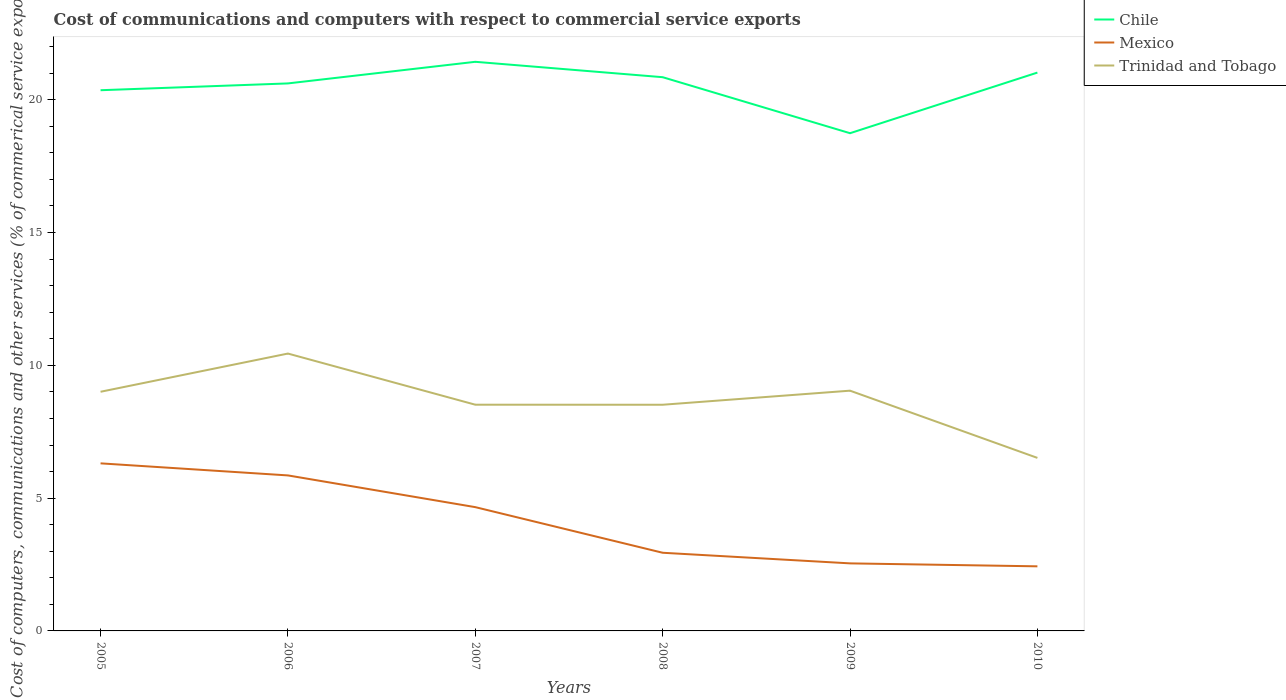Does the line corresponding to Trinidad and Tobago intersect with the line corresponding to Chile?
Provide a succinct answer. No. Across all years, what is the maximum cost of communications and computers in Trinidad and Tobago?
Make the answer very short. 6.51. What is the total cost of communications and computers in Trinidad and Tobago in the graph?
Provide a short and direct response. 2. What is the difference between the highest and the second highest cost of communications and computers in Trinidad and Tobago?
Your answer should be very brief. 3.93. Is the cost of communications and computers in Chile strictly greater than the cost of communications and computers in Mexico over the years?
Your answer should be very brief. No. Does the graph contain grids?
Provide a succinct answer. No. Where does the legend appear in the graph?
Your response must be concise. Top right. How many legend labels are there?
Keep it short and to the point. 3. How are the legend labels stacked?
Keep it short and to the point. Vertical. What is the title of the graph?
Your response must be concise. Cost of communications and computers with respect to commercial service exports. Does "France" appear as one of the legend labels in the graph?
Your answer should be compact. No. What is the label or title of the X-axis?
Keep it short and to the point. Years. What is the label or title of the Y-axis?
Your answer should be very brief. Cost of computers, communications and other services (% of commerical service exports). What is the Cost of computers, communications and other services (% of commerical service exports) of Chile in 2005?
Make the answer very short. 20.36. What is the Cost of computers, communications and other services (% of commerical service exports) of Mexico in 2005?
Make the answer very short. 6.31. What is the Cost of computers, communications and other services (% of commerical service exports) of Trinidad and Tobago in 2005?
Provide a short and direct response. 9. What is the Cost of computers, communications and other services (% of commerical service exports) in Chile in 2006?
Keep it short and to the point. 20.61. What is the Cost of computers, communications and other services (% of commerical service exports) in Mexico in 2006?
Offer a terse response. 5.85. What is the Cost of computers, communications and other services (% of commerical service exports) in Trinidad and Tobago in 2006?
Offer a terse response. 10.44. What is the Cost of computers, communications and other services (% of commerical service exports) of Chile in 2007?
Provide a short and direct response. 21.43. What is the Cost of computers, communications and other services (% of commerical service exports) of Mexico in 2007?
Your answer should be very brief. 4.66. What is the Cost of computers, communications and other services (% of commerical service exports) in Trinidad and Tobago in 2007?
Your answer should be compact. 8.52. What is the Cost of computers, communications and other services (% of commerical service exports) in Chile in 2008?
Keep it short and to the point. 20.85. What is the Cost of computers, communications and other services (% of commerical service exports) of Mexico in 2008?
Offer a very short reply. 2.94. What is the Cost of computers, communications and other services (% of commerical service exports) in Trinidad and Tobago in 2008?
Provide a short and direct response. 8.52. What is the Cost of computers, communications and other services (% of commerical service exports) in Chile in 2009?
Provide a short and direct response. 18.74. What is the Cost of computers, communications and other services (% of commerical service exports) in Mexico in 2009?
Keep it short and to the point. 2.54. What is the Cost of computers, communications and other services (% of commerical service exports) of Trinidad and Tobago in 2009?
Your answer should be compact. 9.05. What is the Cost of computers, communications and other services (% of commerical service exports) in Chile in 2010?
Give a very brief answer. 21.02. What is the Cost of computers, communications and other services (% of commerical service exports) in Mexico in 2010?
Offer a very short reply. 2.43. What is the Cost of computers, communications and other services (% of commerical service exports) in Trinidad and Tobago in 2010?
Give a very brief answer. 6.51. Across all years, what is the maximum Cost of computers, communications and other services (% of commerical service exports) in Chile?
Provide a succinct answer. 21.43. Across all years, what is the maximum Cost of computers, communications and other services (% of commerical service exports) of Mexico?
Your response must be concise. 6.31. Across all years, what is the maximum Cost of computers, communications and other services (% of commerical service exports) in Trinidad and Tobago?
Your answer should be very brief. 10.44. Across all years, what is the minimum Cost of computers, communications and other services (% of commerical service exports) of Chile?
Provide a succinct answer. 18.74. Across all years, what is the minimum Cost of computers, communications and other services (% of commerical service exports) in Mexico?
Provide a short and direct response. 2.43. Across all years, what is the minimum Cost of computers, communications and other services (% of commerical service exports) in Trinidad and Tobago?
Ensure brevity in your answer.  6.51. What is the total Cost of computers, communications and other services (% of commerical service exports) of Chile in the graph?
Give a very brief answer. 123.01. What is the total Cost of computers, communications and other services (% of commerical service exports) of Mexico in the graph?
Keep it short and to the point. 24.74. What is the total Cost of computers, communications and other services (% of commerical service exports) of Trinidad and Tobago in the graph?
Your answer should be very brief. 52.04. What is the difference between the Cost of computers, communications and other services (% of commerical service exports) of Chile in 2005 and that in 2006?
Your answer should be very brief. -0.26. What is the difference between the Cost of computers, communications and other services (% of commerical service exports) in Mexico in 2005 and that in 2006?
Give a very brief answer. 0.45. What is the difference between the Cost of computers, communications and other services (% of commerical service exports) in Trinidad and Tobago in 2005 and that in 2006?
Ensure brevity in your answer.  -1.44. What is the difference between the Cost of computers, communications and other services (% of commerical service exports) of Chile in 2005 and that in 2007?
Provide a short and direct response. -1.07. What is the difference between the Cost of computers, communications and other services (% of commerical service exports) of Mexico in 2005 and that in 2007?
Make the answer very short. 1.65. What is the difference between the Cost of computers, communications and other services (% of commerical service exports) of Trinidad and Tobago in 2005 and that in 2007?
Offer a very short reply. 0.49. What is the difference between the Cost of computers, communications and other services (% of commerical service exports) in Chile in 2005 and that in 2008?
Offer a terse response. -0.49. What is the difference between the Cost of computers, communications and other services (% of commerical service exports) of Mexico in 2005 and that in 2008?
Provide a succinct answer. 3.37. What is the difference between the Cost of computers, communications and other services (% of commerical service exports) of Trinidad and Tobago in 2005 and that in 2008?
Keep it short and to the point. 0.49. What is the difference between the Cost of computers, communications and other services (% of commerical service exports) in Chile in 2005 and that in 2009?
Keep it short and to the point. 1.62. What is the difference between the Cost of computers, communications and other services (% of commerical service exports) of Mexico in 2005 and that in 2009?
Offer a very short reply. 3.77. What is the difference between the Cost of computers, communications and other services (% of commerical service exports) in Trinidad and Tobago in 2005 and that in 2009?
Your answer should be compact. -0.04. What is the difference between the Cost of computers, communications and other services (% of commerical service exports) in Chile in 2005 and that in 2010?
Offer a terse response. -0.66. What is the difference between the Cost of computers, communications and other services (% of commerical service exports) of Mexico in 2005 and that in 2010?
Your answer should be compact. 3.88. What is the difference between the Cost of computers, communications and other services (% of commerical service exports) in Trinidad and Tobago in 2005 and that in 2010?
Provide a short and direct response. 2.49. What is the difference between the Cost of computers, communications and other services (% of commerical service exports) in Chile in 2006 and that in 2007?
Your answer should be very brief. -0.81. What is the difference between the Cost of computers, communications and other services (% of commerical service exports) in Mexico in 2006 and that in 2007?
Keep it short and to the point. 1.19. What is the difference between the Cost of computers, communications and other services (% of commerical service exports) in Trinidad and Tobago in 2006 and that in 2007?
Provide a short and direct response. 1.93. What is the difference between the Cost of computers, communications and other services (% of commerical service exports) of Chile in 2006 and that in 2008?
Keep it short and to the point. -0.23. What is the difference between the Cost of computers, communications and other services (% of commerical service exports) in Mexico in 2006 and that in 2008?
Keep it short and to the point. 2.91. What is the difference between the Cost of computers, communications and other services (% of commerical service exports) of Trinidad and Tobago in 2006 and that in 2008?
Give a very brief answer. 1.93. What is the difference between the Cost of computers, communications and other services (% of commerical service exports) of Chile in 2006 and that in 2009?
Provide a succinct answer. 1.87. What is the difference between the Cost of computers, communications and other services (% of commerical service exports) of Mexico in 2006 and that in 2009?
Make the answer very short. 3.31. What is the difference between the Cost of computers, communications and other services (% of commerical service exports) in Trinidad and Tobago in 2006 and that in 2009?
Provide a succinct answer. 1.4. What is the difference between the Cost of computers, communications and other services (% of commerical service exports) of Chile in 2006 and that in 2010?
Provide a short and direct response. -0.41. What is the difference between the Cost of computers, communications and other services (% of commerical service exports) in Mexico in 2006 and that in 2010?
Your response must be concise. 3.42. What is the difference between the Cost of computers, communications and other services (% of commerical service exports) in Trinidad and Tobago in 2006 and that in 2010?
Offer a very short reply. 3.93. What is the difference between the Cost of computers, communications and other services (% of commerical service exports) in Chile in 2007 and that in 2008?
Give a very brief answer. 0.58. What is the difference between the Cost of computers, communications and other services (% of commerical service exports) of Mexico in 2007 and that in 2008?
Provide a short and direct response. 1.72. What is the difference between the Cost of computers, communications and other services (% of commerical service exports) of Trinidad and Tobago in 2007 and that in 2008?
Make the answer very short. 0. What is the difference between the Cost of computers, communications and other services (% of commerical service exports) of Chile in 2007 and that in 2009?
Make the answer very short. 2.69. What is the difference between the Cost of computers, communications and other services (% of commerical service exports) of Mexico in 2007 and that in 2009?
Provide a short and direct response. 2.12. What is the difference between the Cost of computers, communications and other services (% of commerical service exports) of Trinidad and Tobago in 2007 and that in 2009?
Provide a short and direct response. -0.53. What is the difference between the Cost of computers, communications and other services (% of commerical service exports) in Chile in 2007 and that in 2010?
Provide a short and direct response. 0.41. What is the difference between the Cost of computers, communications and other services (% of commerical service exports) of Mexico in 2007 and that in 2010?
Provide a succinct answer. 2.23. What is the difference between the Cost of computers, communications and other services (% of commerical service exports) of Trinidad and Tobago in 2007 and that in 2010?
Give a very brief answer. 2. What is the difference between the Cost of computers, communications and other services (% of commerical service exports) of Chile in 2008 and that in 2009?
Provide a short and direct response. 2.11. What is the difference between the Cost of computers, communications and other services (% of commerical service exports) of Mexico in 2008 and that in 2009?
Offer a terse response. 0.4. What is the difference between the Cost of computers, communications and other services (% of commerical service exports) in Trinidad and Tobago in 2008 and that in 2009?
Give a very brief answer. -0.53. What is the difference between the Cost of computers, communications and other services (% of commerical service exports) in Chile in 2008 and that in 2010?
Offer a terse response. -0.17. What is the difference between the Cost of computers, communications and other services (% of commerical service exports) of Mexico in 2008 and that in 2010?
Keep it short and to the point. 0.51. What is the difference between the Cost of computers, communications and other services (% of commerical service exports) in Trinidad and Tobago in 2008 and that in 2010?
Offer a terse response. 2. What is the difference between the Cost of computers, communications and other services (% of commerical service exports) in Chile in 2009 and that in 2010?
Your answer should be compact. -2.28. What is the difference between the Cost of computers, communications and other services (% of commerical service exports) of Mexico in 2009 and that in 2010?
Ensure brevity in your answer.  0.11. What is the difference between the Cost of computers, communications and other services (% of commerical service exports) of Trinidad and Tobago in 2009 and that in 2010?
Your answer should be compact. 2.53. What is the difference between the Cost of computers, communications and other services (% of commerical service exports) in Chile in 2005 and the Cost of computers, communications and other services (% of commerical service exports) in Mexico in 2006?
Your answer should be very brief. 14.5. What is the difference between the Cost of computers, communications and other services (% of commerical service exports) of Chile in 2005 and the Cost of computers, communications and other services (% of commerical service exports) of Trinidad and Tobago in 2006?
Provide a succinct answer. 9.91. What is the difference between the Cost of computers, communications and other services (% of commerical service exports) of Mexico in 2005 and the Cost of computers, communications and other services (% of commerical service exports) of Trinidad and Tobago in 2006?
Your answer should be very brief. -4.13. What is the difference between the Cost of computers, communications and other services (% of commerical service exports) in Chile in 2005 and the Cost of computers, communications and other services (% of commerical service exports) in Mexico in 2007?
Make the answer very short. 15.7. What is the difference between the Cost of computers, communications and other services (% of commerical service exports) of Chile in 2005 and the Cost of computers, communications and other services (% of commerical service exports) of Trinidad and Tobago in 2007?
Offer a terse response. 11.84. What is the difference between the Cost of computers, communications and other services (% of commerical service exports) of Mexico in 2005 and the Cost of computers, communications and other services (% of commerical service exports) of Trinidad and Tobago in 2007?
Give a very brief answer. -2.21. What is the difference between the Cost of computers, communications and other services (% of commerical service exports) of Chile in 2005 and the Cost of computers, communications and other services (% of commerical service exports) of Mexico in 2008?
Ensure brevity in your answer.  17.41. What is the difference between the Cost of computers, communications and other services (% of commerical service exports) of Chile in 2005 and the Cost of computers, communications and other services (% of commerical service exports) of Trinidad and Tobago in 2008?
Give a very brief answer. 11.84. What is the difference between the Cost of computers, communications and other services (% of commerical service exports) of Mexico in 2005 and the Cost of computers, communications and other services (% of commerical service exports) of Trinidad and Tobago in 2008?
Your answer should be compact. -2.21. What is the difference between the Cost of computers, communications and other services (% of commerical service exports) in Chile in 2005 and the Cost of computers, communications and other services (% of commerical service exports) in Mexico in 2009?
Your response must be concise. 17.81. What is the difference between the Cost of computers, communications and other services (% of commerical service exports) in Chile in 2005 and the Cost of computers, communications and other services (% of commerical service exports) in Trinidad and Tobago in 2009?
Your answer should be very brief. 11.31. What is the difference between the Cost of computers, communications and other services (% of commerical service exports) of Mexico in 2005 and the Cost of computers, communications and other services (% of commerical service exports) of Trinidad and Tobago in 2009?
Provide a short and direct response. -2.74. What is the difference between the Cost of computers, communications and other services (% of commerical service exports) in Chile in 2005 and the Cost of computers, communications and other services (% of commerical service exports) in Mexico in 2010?
Keep it short and to the point. 17.93. What is the difference between the Cost of computers, communications and other services (% of commerical service exports) in Chile in 2005 and the Cost of computers, communications and other services (% of commerical service exports) in Trinidad and Tobago in 2010?
Offer a terse response. 13.84. What is the difference between the Cost of computers, communications and other services (% of commerical service exports) of Mexico in 2005 and the Cost of computers, communications and other services (% of commerical service exports) of Trinidad and Tobago in 2010?
Offer a very short reply. -0.21. What is the difference between the Cost of computers, communications and other services (% of commerical service exports) in Chile in 2006 and the Cost of computers, communications and other services (% of commerical service exports) in Mexico in 2007?
Provide a short and direct response. 15.95. What is the difference between the Cost of computers, communications and other services (% of commerical service exports) of Chile in 2006 and the Cost of computers, communications and other services (% of commerical service exports) of Trinidad and Tobago in 2007?
Your response must be concise. 12.1. What is the difference between the Cost of computers, communications and other services (% of commerical service exports) in Mexico in 2006 and the Cost of computers, communications and other services (% of commerical service exports) in Trinidad and Tobago in 2007?
Your answer should be compact. -2.66. What is the difference between the Cost of computers, communications and other services (% of commerical service exports) of Chile in 2006 and the Cost of computers, communications and other services (% of commerical service exports) of Mexico in 2008?
Keep it short and to the point. 17.67. What is the difference between the Cost of computers, communications and other services (% of commerical service exports) in Chile in 2006 and the Cost of computers, communications and other services (% of commerical service exports) in Trinidad and Tobago in 2008?
Your answer should be very brief. 12.1. What is the difference between the Cost of computers, communications and other services (% of commerical service exports) in Mexico in 2006 and the Cost of computers, communications and other services (% of commerical service exports) in Trinidad and Tobago in 2008?
Keep it short and to the point. -2.66. What is the difference between the Cost of computers, communications and other services (% of commerical service exports) of Chile in 2006 and the Cost of computers, communications and other services (% of commerical service exports) of Mexico in 2009?
Provide a short and direct response. 18.07. What is the difference between the Cost of computers, communications and other services (% of commerical service exports) in Chile in 2006 and the Cost of computers, communications and other services (% of commerical service exports) in Trinidad and Tobago in 2009?
Provide a succinct answer. 11.57. What is the difference between the Cost of computers, communications and other services (% of commerical service exports) of Mexico in 2006 and the Cost of computers, communications and other services (% of commerical service exports) of Trinidad and Tobago in 2009?
Your answer should be compact. -3.19. What is the difference between the Cost of computers, communications and other services (% of commerical service exports) of Chile in 2006 and the Cost of computers, communications and other services (% of commerical service exports) of Mexico in 2010?
Keep it short and to the point. 18.18. What is the difference between the Cost of computers, communications and other services (% of commerical service exports) in Chile in 2006 and the Cost of computers, communications and other services (% of commerical service exports) in Trinidad and Tobago in 2010?
Keep it short and to the point. 14.1. What is the difference between the Cost of computers, communications and other services (% of commerical service exports) of Mexico in 2006 and the Cost of computers, communications and other services (% of commerical service exports) of Trinidad and Tobago in 2010?
Your response must be concise. -0.66. What is the difference between the Cost of computers, communications and other services (% of commerical service exports) in Chile in 2007 and the Cost of computers, communications and other services (% of commerical service exports) in Mexico in 2008?
Keep it short and to the point. 18.48. What is the difference between the Cost of computers, communications and other services (% of commerical service exports) in Chile in 2007 and the Cost of computers, communications and other services (% of commerical service exports) in Trinidad and Tobago in 2008?
Your answer should be very brief. 12.91. What is the difference between the Cost of computers, communications and other services (% of commerical service exports) of Mexico in 2007 and the Cost of computers, communications and other services (% of commerical service exports) of Trinidad and Tobago in 2008?
Give a very brief answer. -3.86. What is the difference between the Cost of computers, communications and other services (% of commerical service exports) in Chile in 2007 and the Cost of computers, communications and other services (% of commerical service exports) in Mexico in 2009?
Make the answer very short. 18.88. What is the difference between the Cost of computers, communications and other services (% of commerical service exports) in Chile in 2007 and the Cost of computers, communications and other services (% of commerical service exports) in Trinidad and Tobago in 2009?
Your answer should be compact. 12.38. What is the difference between the Cost of computers, communications and other services (% of commerical service exports) of Mexico in 2007 and the Cost of computers, communications and other services (% of commerical service exports) of Trinidad and Tobago in 2009?
Provide a succinct answer. -4.38. What is the difference between the Cost of computers, communications and other services (% of commerical service exports) of Chile in 2007 and the Cost of computers, communications and other services (% of commerical service exports) of Mexico in 2010?
Offer a very short reply. 19. What is the difference between the Cost of computers, communications and other services (% of commerical service exports) of Chile in 2007 and the Cost of computers, communications and other services (% of commerical service exports) of Trinidad and Tobago in 2010?
Offer a terse response. 14.91. What is the difference between the Cost of computers, communications and other services (% of commerical service exports) of Mexico in 2007 and the Cost of computers, communications and other services (% of commerical service exports) of Trinidad and Tobago in 2010?
Give a very brief answer. -1.85. What is the difference between the Cost of computers, communications and other services (% of commerical service exports) in Chile in 2008 and the Cost of computers, communications and other services (% of commerical service exports) in Mexico in 2009?
Provide a succinct answer. 18.3. What is the difference between the Cost of computers, communications and other services (% of commerical service exports) of Chile in 2008 and the Cost of computers, communications and other services (% of commerical service exports) of Trinidad and Tobago in 2009?
Your answer should be compact. 11.8. What is the difference between the Cost of computers, communications and other services (% of commerical service exports) in Mexico in 2008 and the Cost of computers, communications and other services (% of commerical service exports) in Trinidad and Tobago in 2009?
Provide a succinct answer. -6.1. What is the difference between the Cost of computers, communications and other services (% of commerical service exports) in Chile in 2008 and the Cost of computers, communications and other services (% of commerical service exports) in Mexico in 2010?
Provide a short and direct response. 18.42. What is the difference between the Cost of computers, communications and other services (% of commerical service exports) of Chile in 2008 and the Cost of computers, communications and other services (% of commerical service exports) of Trinidad and Tobago in 2010?
Your answer should be compact. 14.33. What is the difference between the Cost of computers, communications and other services (% of commerical service exports) of Mexico in 2008 and the Cost of computers, communications and other services (% of commerical service exports) of Trinidad and Tobago in 2010?
Keep it short and to the point. -3.57. What is the difference between the Cost of computers, communications and other services (% of commerical service exports) in Chile in 2009 and the Cost of computers, communications and other services (% of commerical service exports) in Mexico in 2010?
Your response must be concise. 16.31. What is the difference between the Cost of computers, communications and other services (% of commerical service exports) of Chile in 2009 and the Cost of computers, communications and other services (% of commerical service exports) of Trinidad and Tobago in 2010?
Ensure brevity in your answer.  12.22. What is the difference between the Cost of computers, communications and other services (% of commerical service exports) in Mexico in 2009 and the Cost of computers, communications and other services (% of commerical service exports) in Trinidad and Tobago in 2010?
Give a very brief answer. -3.97. What is the average Cost of computers, communications and other services (% of commerical service exports) in Chile per year?
Your answer should be very brief. 20.5. What is the average Cost of computers, communications and other services (% of commerical service exports) in Mexico per year?
Make the answer very short. 4.12. What is the average Cost of computers, communications and other services (% of commerical service exports) of Trinidad and Tobago per year?
Ensure brevity in your answer.  8.67. In the year 2005, what is the difference between the Cost of computers, communications and other services (% of commerical service exports) of Chile and Cost of computers, communications and other services (% of commerical service exports) of Mexico?
Offer a very short reply. 14.05. In the year 2005, what is the difference between the Cost of computers, communications and other services (% of commerical service exports) in Chile and Cost of computers, communications and other services (% of commerical service exports) in Trinidad and Tobago?
Offer a terse response. 11.35. In the year 2005, what is the difference between the Cost of computers, communications and other services (% of commerical service exports) of Mexico and Cost of computers, communications and other services (% of commerical service exports) of Trinidad and Tobago?
Your answer should be compact. -2.7. In the year 2006, what is the difference between the Cost of computers, communications and other services (% of commerical service exports) of Chile and Cost of computers, communications and other services (% of commerical service exports) of Mexico?
Make the answer very short. 14.76. In the year 2006, what is the difference between the Cost of computers, communications and other services (% of commerical service exports) of Chile and Cost of computers, communications and other services (% of commerical service exports) of Trinidad and Tobago?
Make the answer very short. 10.17. In the year 2006, what is the difference between the Cost of computers, communications and other services (% of commerical service exports) of Mexico and Cost of computers, communications and other services (% of commerical service exports) of Trinidad and Tobago?
Give a very brief answer. -4.59. In the year 2007, what is the difference between the Cost of computers, communications and other services (% of commerical service exports) of Chile and Cost of computers, communications and other services (% of commerical service exports) of Mexico?
Offer a terse response. 16.77. In the year 2007, what is the difference between the Cost of computers, communications and other services (% of commerical service exports) in Chile and Cost of computers, communications and other services (% of commerical service exports) in Trinidad and Tobago?
Offer a very short reply. 12.91. In the year 2007, what is the difference between the Cost of computers, communications and other services (% of commerical service exports) in Mexico and Cost of computers, communications and other services (% of commerical service exports) in Trinidad and Tobago?
Keep it short and to the point. -3.86. In the year 2008, what is the difference between the Cost of computers, communications and other services (% of commerical service exports) in Chile and Cost of computers, communications and other services (% of commerical service exports) in Mexico?
Make the answer very short. 17.91. In the year 2008, what is the difference between the Cost of computers, communications and other services (% of commerical service exports) in Chile and Cost of computers, communications and other services (% of commerical service exports) in Trinidad and Tobago?
Make the answer very short. 12.33. In the year 2008, what is the difference between the Cost of computers, communications and other services (% of commerical service exports) of Mexico and Cost of computers, communications and other services (% of commerical service exports) of Trinidad and Tobago?
Your answer should be very brief. -5.57. In the year 2009, what is the difference between the Cost of computers, communications and other services (% of commerical service exports) in Chile and Cost of computers, communications and other services (% of commerical service exports) in Mexico?
Keep it short and to the point. 16.2. In the year 2009, what is the difference between the Cost of computers, communications and other services (% of commerical service exports) in Chile and Cost of computers, communications and other services (% of commerical service exports) in Trinidad and Tobago?
Keep it short and to the point. 9.69. In the year 2009, what is the difference between the Cost of computers, communications and other services (% of commerical service exports) of Mexico and Cost of computers, communications and other services (% of commerical service exports) of Trinidad and Tobago?
Make the answer very short. -6.5. In the year 2010, what is the difference between the Cost of computers, communications and other services (% of commerical service exports) in Chile and Cost of computers, communications and other services (% of commerical service exports) in Mexico?
Your answer should be compact. 18.59. In the year 2010, what is the difference between the Cost of computers, communications and other services (% of commerical service exports) in Chile and Cost of computers, communications and other services (% of commerical service exports) in Trinidad and Tobago?
Your answer should be very brief. 14.51. In the year 2010, what is the difference between the Cost of computers, communications and other services (% of commerical service exports) in Mexico and Cost of computers, communications and other services (% of commerical service exports) in Trinidad and Tobago?
Your answer should be compact. -4.08. What is the ratio of the Cost of computers, communications and other services (% of commerical service exports) of Chile in 2005 to that in 2006?
Provide a succinct answer. 0.99. What is the ratio of the Cost of computers, communications and other services (% of commerical service exports) in Mexico in 2005 to that in 2006?
Your response must be concise. 1.08. What is the ratio of the Cost of computers, communications and other services (% of commerical service exports) of Trinidad and Tobago in 2005 to that in 2006?
Provide a short and direct response. 0.86. What is the ratio of the Cost of computers, communications and other services (% of commerical service exports) of Chile in 2005 to that in 2007?
Make the answer very short. 0.95. What is the ratio of the Cost of computers, communications and other services (% of commerical service exports) in Mexico in 2005 to that in 2007?
Ensure brevity in your answer.  1.35. What is the ratio of the Cost of computers, communications and other services (% of commerical service exports) in Trinidad and Tobago in 2005 to that in 2007?
Ensure brevity in your answer.  1.06. What is the ratio of the Cost of computers, communications and other services (% of commerical service exports) in Chile in 2005 to that in 2008?
Provide a succinct answer. 0.98. What is the ratio of the Cost of computers, communications and other services (% of commerical service exports) in Mexico in 2005 to that in 2008?
Offer a very short reply. 2.14. What is the ratio of the Cost of computers, communications and other services (% of commerical service exports) of Trinidad and Tobago in 2005 to that in 2008?
Provide a short and direct response. 1.06. What is the ratio of the Cost of computers, communications and other services (% of commerical service exports) in Chile in 2005 to that in 2009?
Make the answer very short. 1.09. What is the ratio of the Cost of computers, communications and other services (% of commerical service exports) of Mexico in 2005 to that in 2009?
Your answer should be very brief. 2.48. What is the ratio of the Cost of computers, communications and other services (% of commerical service exports) of Trinidad and Tobago in 2005 to that in 2009?
Your response must be concise. 1. What is the ratio of the Cost of computers, communications and other services (% of commerical service exports) of Chile in 2005 to that in 2010?
Provide a short and direct response. 0.97. What is the ratio of the Cost of computers, communications and other services (% of commerical service exports) of Mexico in 2005 to that in 2010?
Your answer should be very brief. 2.59. What is the ratio of the Cost of computers, communications and other services (% of commerical service exports) in Trinidad and Tobago in 2005 to that in 2010?
Offer a very short reply. 1.38. What is the ratio of the Cost of computers, communications and other services (% of commerical service exports) in Chile in 2006 to that in 2007?
Offer a very short reply. 0.96. What is the ratio of the Cost of computers, communications and other services (% of commerical service exports) of Mexico in 2006 to that in 2007?
Your answer should be compact. 1.26. What is the ratio of the Cost of computers, communications and other services (% of commerical service exports) of Trinidad and Tobago in 2006 to that in 2007?
Provide a succinct answer. 1.23. What is the ratio of the Cost of computers, communications and other services (% of commerical service exports) in Chile in 2006 to that in 2008?
Offer a very short reply. 0.99. What is the ratio of the Cost of computers, communications and other services (% of commerical service exports) of Mexico in 2006 to that in 2008?
Ensure brevity in your answer.  1.99. What is the ratio of the Cost of computers, communications and other services (% of commerical service exports) in Trinidad and Tobago in 2006 to that in 2008?
Make the answer very short. 1.23. What is the ratio of the Cost of computers, communications and other services (% of commerical service exports) in Chile in 2006 to that in 2009?
Your answer should be compact. 1.1. What is the ratio of the Cost of computers, communications and other services (% of commerical service exports) in Mexico in 2006 to that in 2009?
Offer a very short reply. 2.3. What is the ratio of the Cost of computers, communications and other services (% of commerical service exports) of Trinidad and Tobago in 2006 to that in 2009?
Offer a very short reply. 1.15. What is the ratio of the Cost of computers, communications and other services (% of commerical service exports) of Chile in 2006 to that in 2010?
Give a very brief answer. 0.98. What is the ratio of the Cost of computers, communications and other services (% of commerical service exports) of Mexico in 2006 to that in 2010?
Your answer should be very brief. 2.41. What is the ratio of the Cost of computers, communications and other services (% of commerical service exports) of Trinidad and Tobago in 2006 to that in 2010?
Your response must be concise. 1.6. What is the ratio of the Cost of computers, communications and other services (% of commerical service exports) of Chile in 2007 to that in 2008?
Make the answer very short. 1.03. What is the ratio of the Cost of computers, communications and other services (% of commerical service exports) in Mexico in 2007 to that in 2008?
Your answer should be compact. 1.58. What is the ratio of the Cost of computers, communications and other services (% of commerical service exports) in Trinidad and Tobago in 2007 to that in 2008?
Provide a short and direct response. 1. What is the ratio of the Cost of computers, communications and other services (% of commerical service exports) in Chile in 2007 to that in 2009?
Ensure brevity in your answer.  1.14. What is the ratio of the Cost of computers, communications and other services (% of commerical service exports) in Mexico in 2007 to that in 2009?
Provide a succinct answer. 1.83. What is the ratio of the Cost of computers, communications and other services (% of commerical service exports) of Trinidad and Tobago in 2007 to that in 2009?
Ensure brevity in your answer.  0.94. What is the ratio of the Cost of computers, communications and other services (% of commerical service exports) of Chile in 2007 to that in 2010?
Offer a terse response. 1.02. What is the ratio of the Cost of computers, communications and other services (% of commerical service exports) in Mexico in 2007 to that in 2010?
Offer a very short reply. 1.92. What is the ratio of the Cost of computers, communications and other services (% of commerical service exports) in Trinidad and Tobago in 2007 to that in 2010?
Keep it short and to the point. 1.31. What is the ratio of the Cost of computers, communications and other services (% of commerical service exports) in Chile in 2008 to that in 2009?
Your response must be concise. 1.11. What is the ratio of the Cost of computers, communications and other services (% of commerical service exports) of Mexico in 2008 to that in 2009?
Your answer should be very brief. 1.16. What is the ratio of the Cost of computers, communications and other services (% of commerical service exports) in Trinidad and Tobago in 2008 to that in 2009?
Your response must be concise. 0.94. What is the ratio of the Cost of computers, communications and other services (% of commerical service exports) in Mexico in 2008 to that in 2010?
Give a very brief answer. 1.21. What is the ratio of the Cost of computers, communications and other services (% of commerical service exports) of Trinidad and Tobago in 2008 to that in 2010?
Your response must be concise. 1.31. What is the ratio of the Cost of computers, communications and other services (% of commerical service exports) of Chile in 2009 to that in 2010?
Your answer should be very brief. 0.89. What is the ratio of the Cost of computers, communications and other services (% of commerical service exports) in Mexico in 2009 to that in 2010?
Ensure brevity in your answer.  1.05. What is the ratio of the Cost of computers, communications and other services (% of commerical service exports) in Trinidad and Tobago in 2009 to that in 2010?
Offer a very short reply. 1.39. What is the difference between the highest and the second highest Cost of computers, communications and other services (% of commerical service exports) of Chile?
Your answer should be very brief. 0.41. What is the difference between the highest and the second highest Cost of computers, communications and other services (% of commerical service exports) in Mexico?
Ensure brevity in your answer.  0.45. What is the difference between the highest and the second highest Cost of computers, communications and other services (% of commerical service exports) in Trinidad and Tobago?
Ensure brevity in your answer.  1.4. What is the difference between the highest and the lowest Cost of computers, communications and other services (% of commerical service exports) of Chile?
Offer a very short reply. 2.69. What is the difference between the highest and the lowest Cost of computers, communications and other services (% of commerical service exports) in Mexico?
Keep it short and to the point. 3.88. What is the difference between the highest and the lowest Cost of computers, communications and other services (% of commerical service exports) of Trinidad and Tobago?
Offer a terse response. 3.93. 